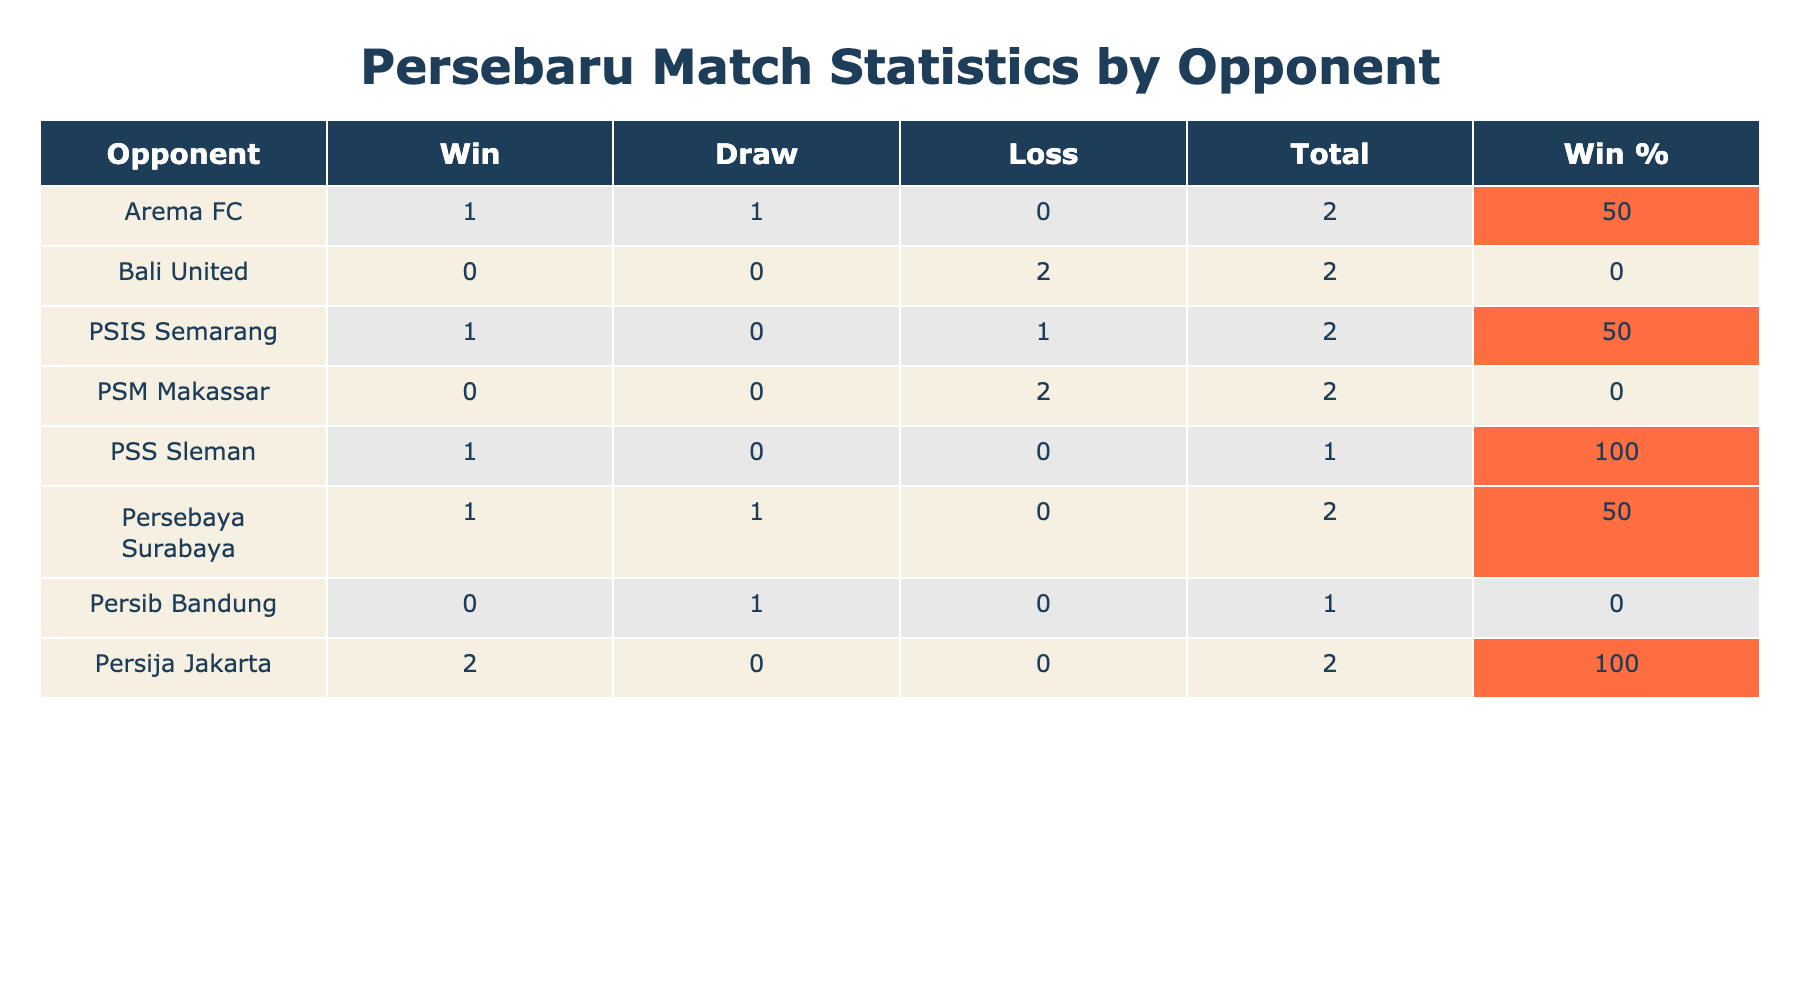What is the total number of matches played against Bali United? To answer this, we look at the row for Bali United in the table. The "Total" column shows the number of matches played against this opponent, which is 3.
Answer: 3 How many matches did Persebaru win against Persebaya Surabaya? Looking at the row for Persebaya Surabaya, the "Win" column indicates that Persebaru won 1 match against this opponent.
Answer: 1 What is the win percentage for matches against PSM Makassar? For PSM Makassar, we find the number of wins (0) and total matches played (3) in the table. The win percentage is calculated as (0 wins / 3 total matches) * 100 = 0%.
Answer: 0% Which opponent did Persebaru have the highest win percentage against? To find this, we need to look through the "Win %" column across all opponents. PSIS Semarang has the highest win percentage at 66.7%, since Persebaru won 2 out of 3 matches against them.
Answer: PSIS Semarang Is it true that Persebaru lost more matches against Arema FC than they won? Reviewing the row for Arema FC, we see 1 win and 1 loss. The losses (1) are equal to the wins (1), so the statement is false.
Answer: No 